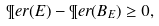Convert formula to latex. <formula><loc_0><loc_0><loc_500><loc_500>\P e r ( E ) - \P e r ( B _ { E } ) \geq 0 ,</formula> 